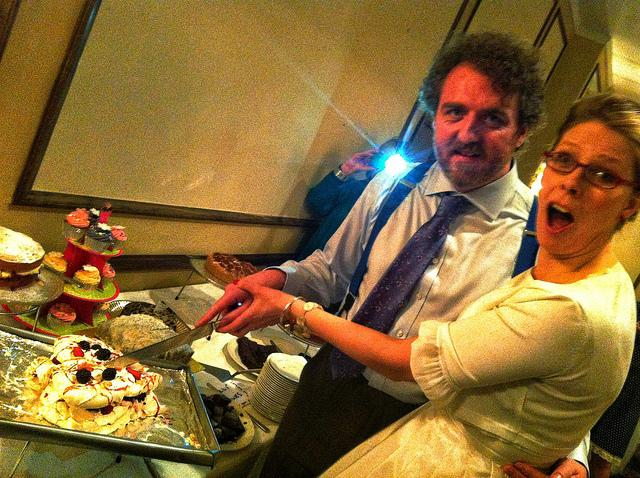Why is the man behind the other two holding a flashing object? Please explain your reasoning. taking pictures. The person appears to be holding a camera and the flash would go off at the moment a picture was taken. the couple also appear to be posing which would also be consistent with answer a. 